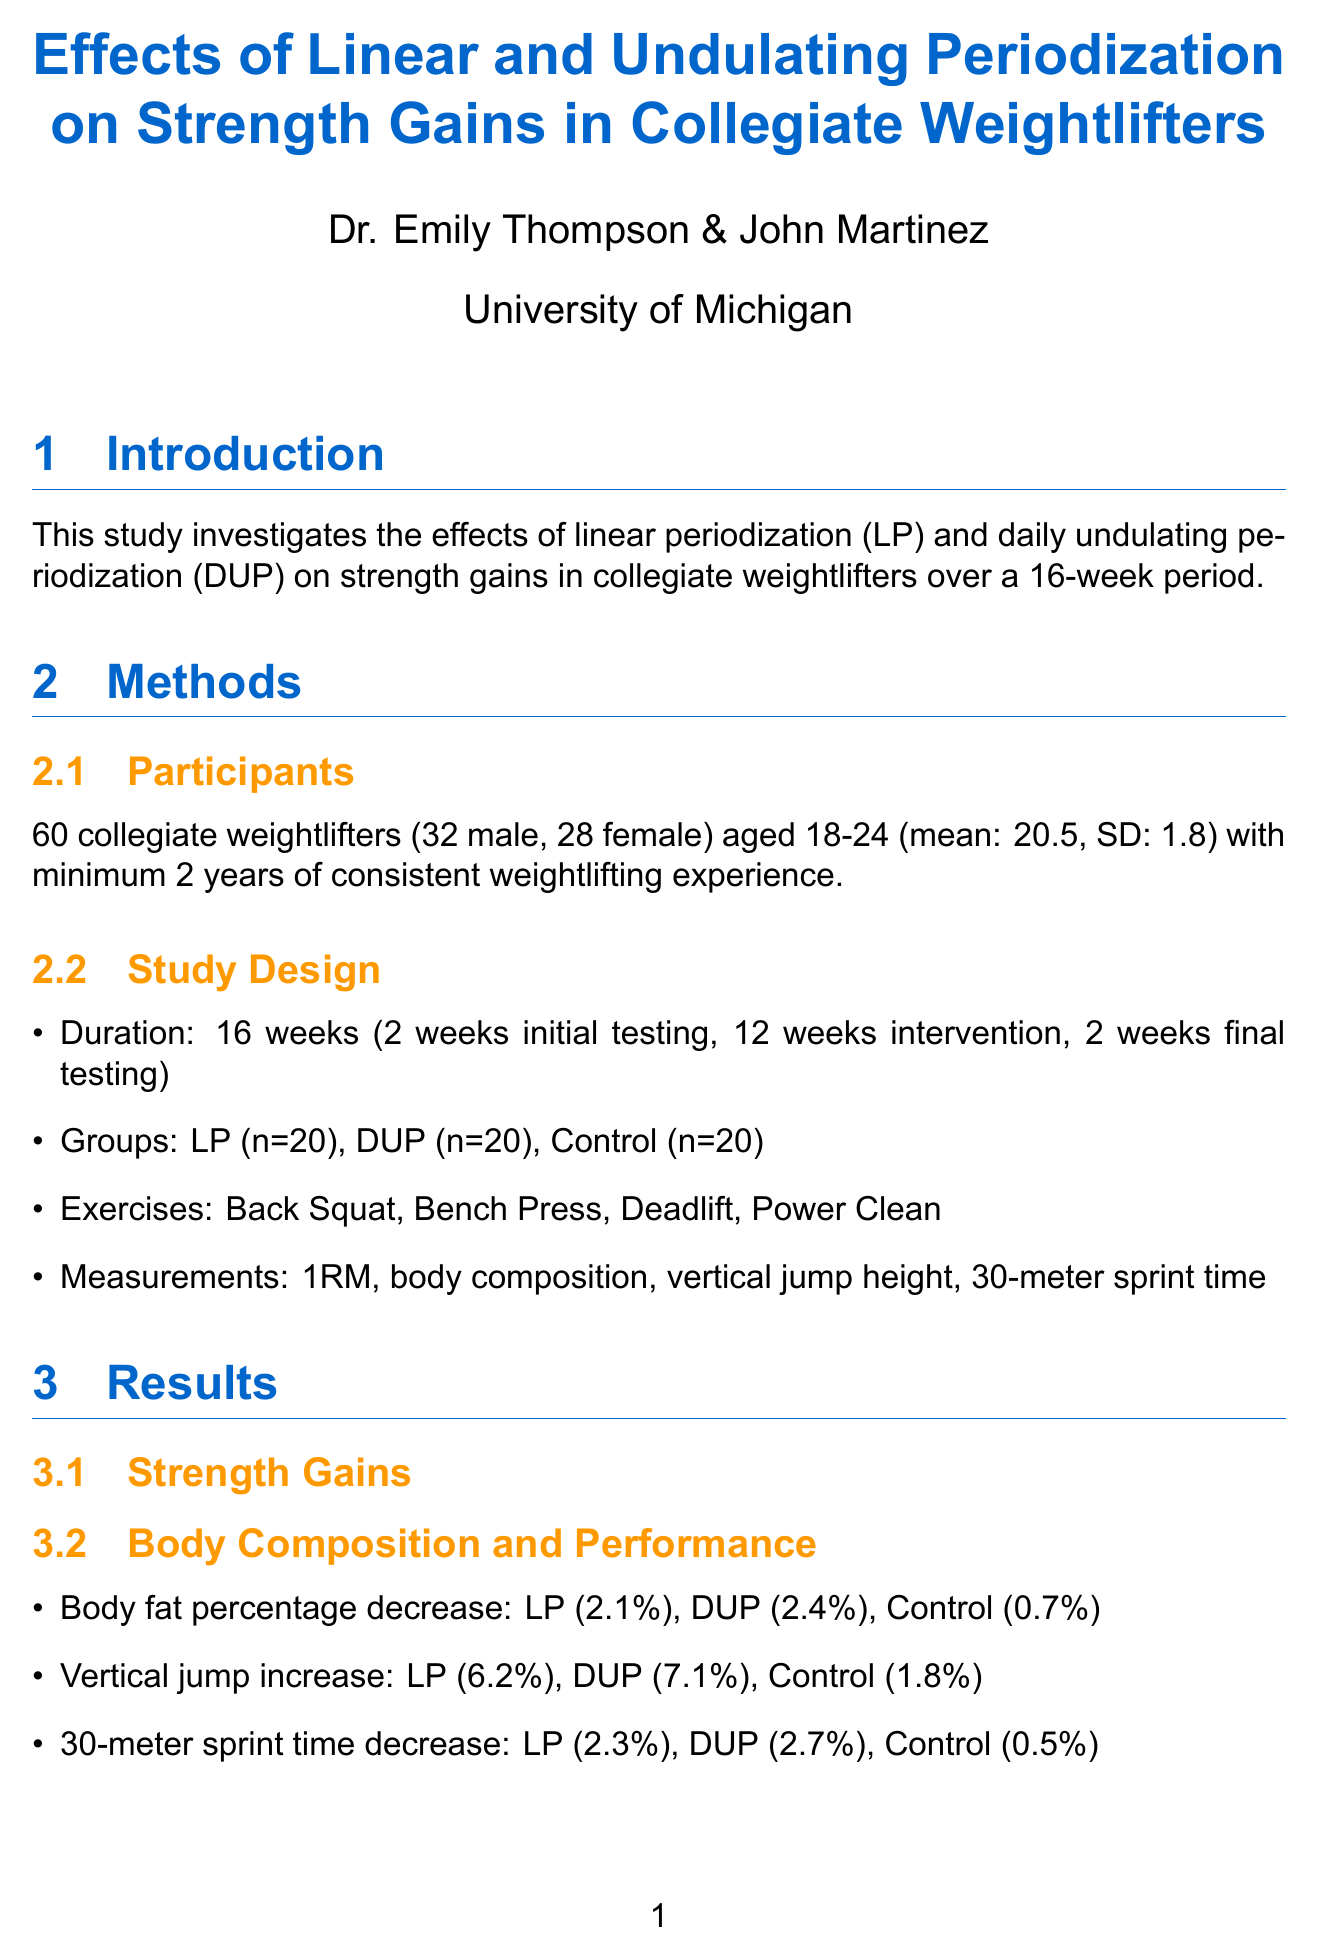What is the main focus of the study? The study investigates the effects of linear periodization and daily undulating periodization on strength gains in collegiate weightlifters.
Answer: Strength gains in collegiate weightlifters Who are the principal investigators of this study? The document lists the principal investigators, including Dr. Emily Thompson and John Martinez.
Answer: Dr. Emily Thompson What is the total number of participants in the study? The document states the total number of collegiate weightlifters involved in the study, which is 60.
Answer: 60 What is the mean age of the participants? The mean age of the participants is provided in the document as part of the demographic information.
Answer: 20.5 What training period duration was used for the intervention? The duration of the training intervention is specified in the methods section of the document.
Answer: 12 weeks Which group showed the highest increase in back squat percentage? The results section indicates the percentage increases in strength gains for each group in the back squat exercise.
Answer: Daily Undulating Periodization (17.6%) What decrease in body fat percentage was observed in the Control group? The document shows the changes in body composition, including body fat percentage decrease for each group.
Answer: 0.7% What statistical analysis method was used in this study? The document lists the specific statistical analysis method utilized to analyze the data collected in the study.
Answer: Repeated measures ANOVA What are the future research suggestions mentioned in the study? The discussion section includes several areas for future research that could be beneficial to explore.
Answer: Investigate long-term effects of different periodization techniques 